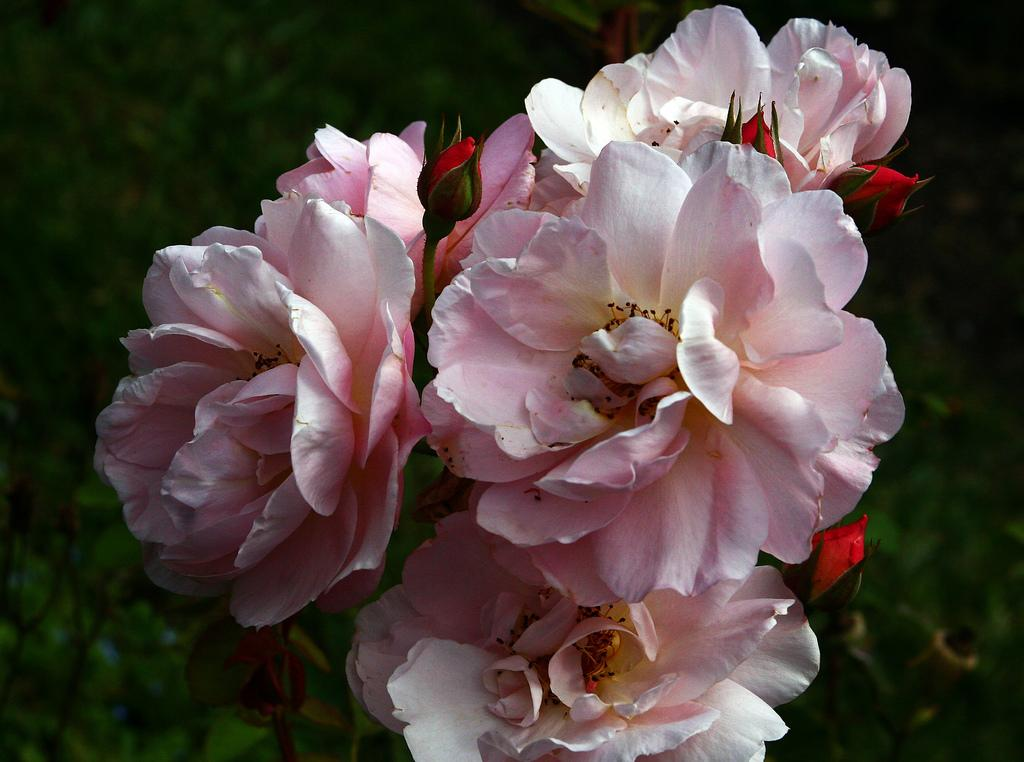What type of flowers are in the image? There is a bunch of rose flowers in the image. What color are the roses? The roses are light pink in color. Can you describe any other features of the flowers? There are flower buds visible in the image. How would you describe the background of the image? The background of the image appears blurry. What type of card is being cooked on the stove in the image? There is no card or stove present in the image; it features a bunch of light pink rose flowers with visible flower buds and a blurry background. 